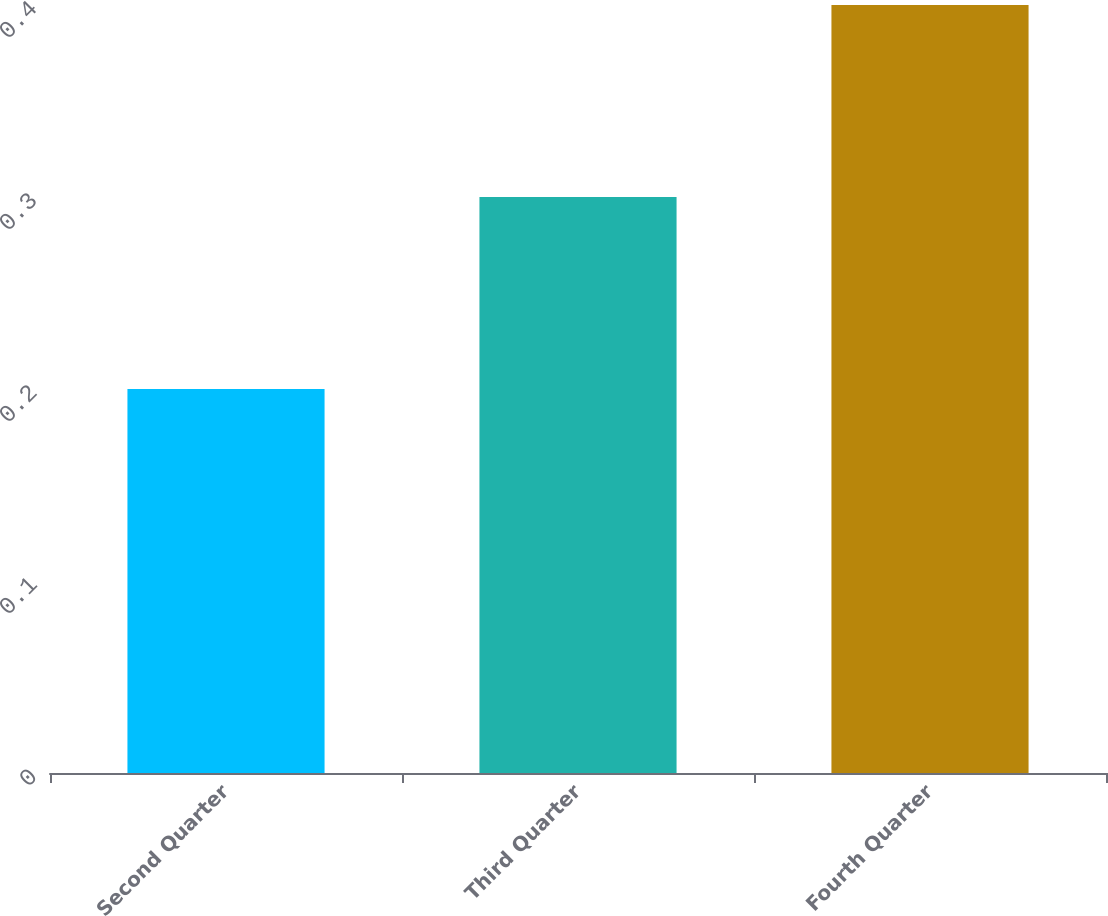Convert chart. <chart><loc_0><loc_0><loc_500><loc_500><bar_chart><fcel>Second Quarter<fcel>Third Quarter<fcel>Fourth Quarter<nl><fcel>0.2<fcel>0.3<fcel>0.4<nl></chart> 